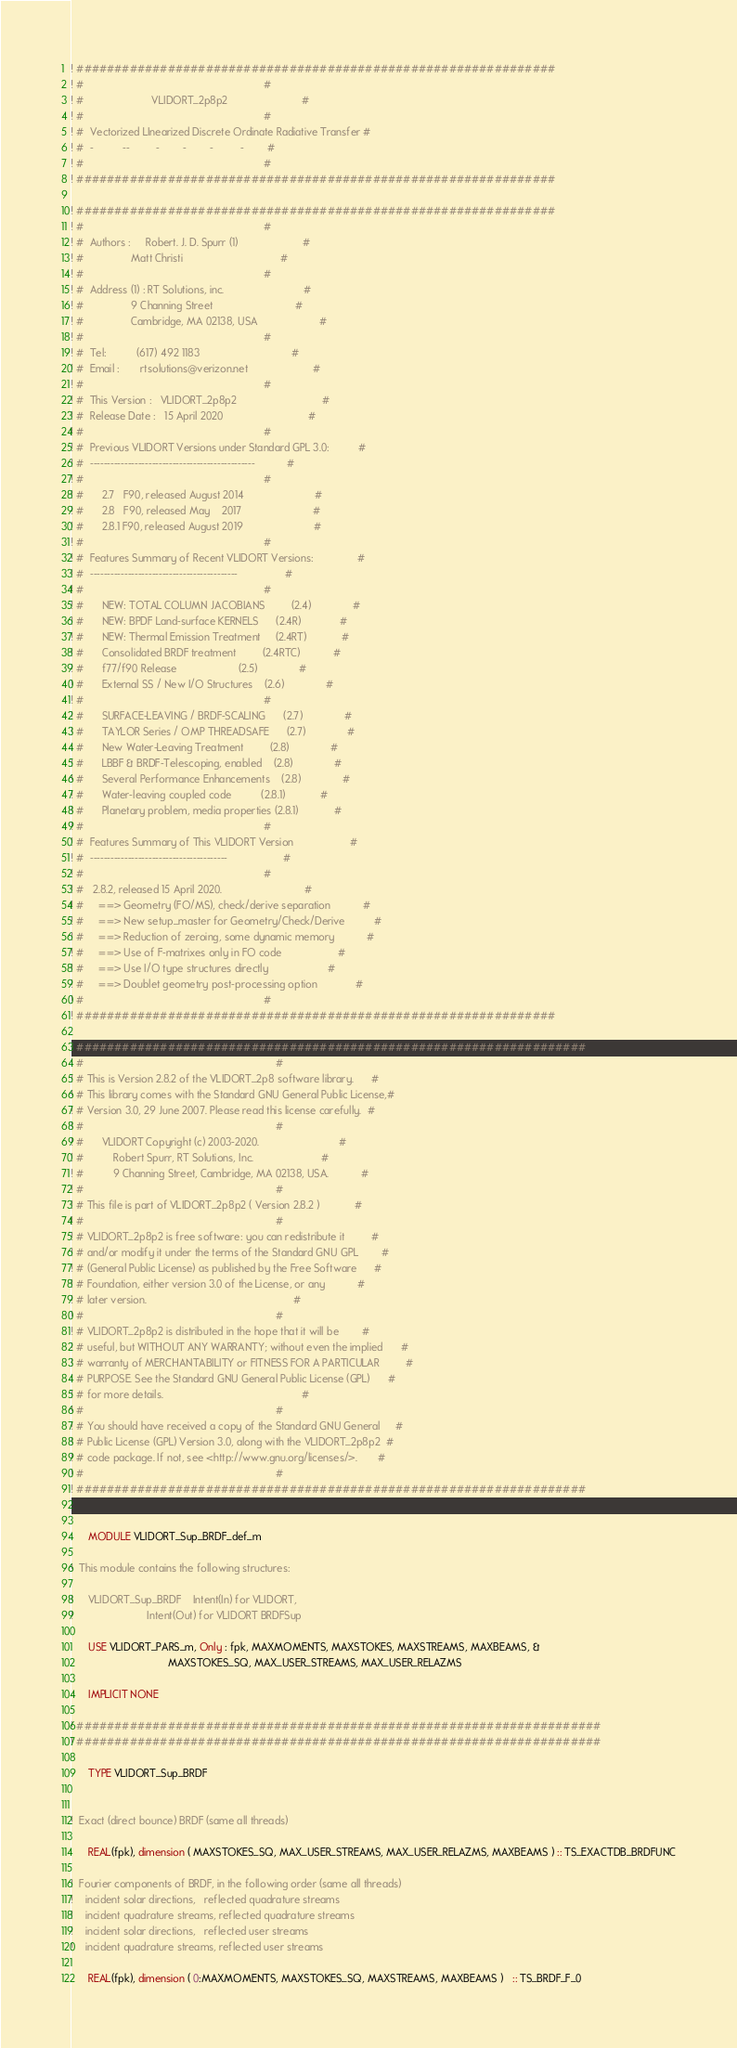Convert code to text. <code><loc_0><loc_0><loc_500><loc_500><_FORTRAN_>
! ###############################################################
! #                                                             #
! #                       VLIDORT_2p8p2                         #
! #                                                             #
! #  Vectorized LInearized Discrete Ordinate Radiative Transfer #
! #  -          --         -        -        -         -        #
! #                                                             #
! ###############################################################

! ###############################################################
! #                                                             #
! #  Authors :     Robert. J. D. Spurr (1)                      #
! #                Matt Christi                                 #
! #                                                             #
! #  Address (1) : RT Solutions, inc.                           #
! #                9 Channing Street                            #
! #                Cambridge, MA 02138, USA                     #
! #                                                             #
! #  Tel:          (617) 492 1183                               #
! #  Email :       rtsolutions@verizon.net                      #
! #                                                             #
! #  This Version :   VLIDORT_2p8p2                             #
! #  Release Date :   15 April 2020                             #
! #                                                             #
! #  Previous VLIDORT Versions under Standard GPL 3.0:          #
! #  ------------------------------------------------           #
! #                                                             #
! #      2.7   F90, released August 2014                        #
! #      2.8   F90, released May    2017                        #
! #      2.8.1 F90, released August 2019                        # 
! #                                                             #
! #  Features Summary of Recent VLIDORT Versions:               #
! #  -------------------------------------------                #
! #                                                             #
! #      NEW: TOTAL COLUMN JACOBIANS         (2.4)              #
! #      NEW: BPDF Land-surface KERNELS      (2.4R)             #
! #      NEW: Thermal Emission Treatment     (2.4RT)            #
! #      Consolidated BRDF treatment         (2.4RTC)           #
! #      f77/f90 Release                     (2.5)              #
! #      External SS / New I/O Structures    (2.6)              #
! #                                                             #
! #      SURFACE-LEAVING / BRDF-SCALING      (2.7)              #
! #      TAYLOR Series / OMP THREADSAFE      (2.7)              #
! #      New Water-Leaving Treatment         (2.8)              #
! #      LBBF & BRDF-Telescoping, enabled    (2.8)              #
! #      Several Performance Enhancements    (2.8)              #
! #      Water-leaving coupled code          (2.8.1)            #
! #      Planetary problem, media properties (2.8.1)            #
! #                                                             #
! #  Features Summary of This VLIDORT Version                   #
! #  ----------------------------------------                   #
! #                                                             #
! #   2.8.2, released 15 April 2020.                            #
! #     ==> Geometry (FO/MS), check/derive separation           #
! #     ==> New setup_master for Geometry/Check/Derive          #
! #     ==> Reduction of zeroing, some dynamic memory           #
! #     ==> Use of F-matrixes only in FO code                   #
! #     ==> Use I/O type structures directly                    #
! #     ==> Doublet geometry post-processing option             #
! #                                                             #
! ###############################################################

! ###################################################################
! #                                                                 #
! # This is Version 2.8.2 of the VLIDORT_2p8 software library.      #
! # This library comes with the Standard GNU General Public License,#
! # Version 3.0, 29 June 2007. Please read this license carefully.  #
! #                                                                 #
! #      VLIDORT Copyright (c) 2003-2020.                           #
! #          Robert Spurr, RT Solutions, Inc.                       #
! #          9 Channing Street, Cambridge, MA 02138, USA.           #
! #                                                                 #
! # This file is part of VLIDORT_2p8p2 ( Version 2.8.2 )            #
! #                                                                 #
! # VLIDORT_2p8p2 is free software: you can redistribute it         #
! # and/or modify it under the terms of the Standard GNU GPL        #
! # (General Public License) as published by the Free Software      #
! # Foundation, either version 3.0 of the License, or any           #
! # later version.                                                  #
! #                                                                 #
! # VLIDORT_2p8p2 is distributed in the hope that it will be        #
! # useful, but WITHOUT ANY WARRANTY; without even the implied      #
! # warranty of MERCHANTABILITY or FITNESS FOR A PARTICULAR         #
! # PURPOSE. See the Standard GNU General Public License (GPL)      #
! # for more details.                                               #
! #                                                                 #
! # You should have received a copy of the Standard GNU General     #
! # Public License (GPL) Version 3.0, along with the VLIDORT_2p8p2  #
! # code package. If not, see <http://www.gnu.org/licenses/>.       #
! #                                                                 #
! ###################################################################


      MODULE VLIDORT_Sup_BRDF_def_m

!  This module contains the following structures:

!     VLIDORT_Sup_BRDF    Intent(In) for VLIDORT,
!                         Intent(Out) for VLIDORT BRDFSup

      USE VLIDORT_PARS_m, Only : fpk, MAXMOMENTS, MAXSTOKES, MAXSTREAMS, MAXBEAMS, &
                                 MAXSTOKES_SQ, MAX_USER_STREAMS, MAX_USER_RELAZMS

      IMPLICIT NONE

! #####################################################################
! #####################################################################

      TYPE VLIDORT_Sup_BRDF


!  Exact (direct bounce) BRDF (same all threads)

      REAL(fpk), dimension ( MAXSTOKES_SQ, MAX_USER_STREAMS, MAX_USER_RELAZMS, MAXBEAMS ) :: TS_EXACTDB_BRDFUNC

!  Fourier components of BRDF, in the following order (same all threads)
!    incident solar directions,   reflected quadrature streams
!    incident quadrature streams, reflected quadrature streams
!    incident solar directions,   reflected user streams
!    incident quadrature streams, reflected user streams

      REAL(fpk), dimension ( 0:MAXMOMENTS, MAXSTOKES_SQ, MAXSTREAMS, MAXBEAMS )   :: TS_BRDF_F_0</code> 